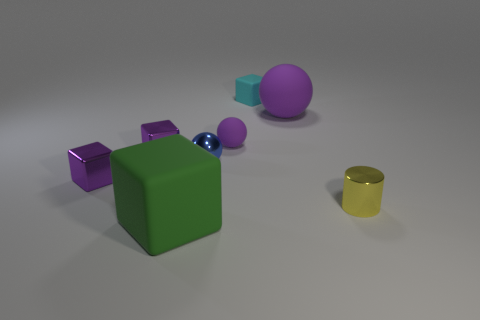Is the color of the rubber cube behind the tiny yellow thing the same as the metal cylinder?
Your response must be concise. No. How many other things are the same color as the shiny ball?
Offer a very short reply. 0. What number of tiny things are either blue things or green matte things?
Keep it short and to the point. 1. Are there more purple matte balls than cyan objects?
Offer a terse response. Yes. Do the blue ball and the cyan block have the same material?
Offer a very short reply. No. Are there any other things that have the same material as the cyan thing?
Provide a short and direct response. Yes. Are there more tiny yellow cylinders on the left side of the blue shiny ball than metallic spheres?
Your answer should be very brief. No. Is the color of the big rubber sphere the same as the tiny cylinder?
Provide a short and direct response. No. What number of other large objects are the same shape as the blue metallic object?
Give a very brief answer. 1. What is the size of the blue thing that is made of the same material as the yellow cylinder?
Provide a succinct answer. Small. 